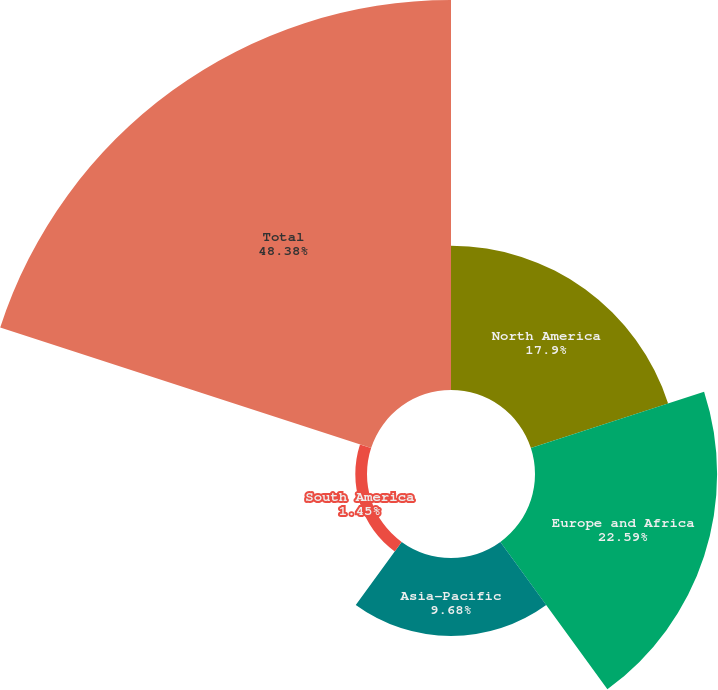Convert chart to OTSL. <chart><loc_0><loc_0><loc_500><loc_500><pie_chart><fcel>North America<fcel>Europe and Africa<fcel>Asia-Pacific<fcel>South America<fcel>Total<nl><fcel>17.9%<fcel>22.59%<fcel>9.68%<fcel>1.45%<fcel>48.38%<nl></chart> 